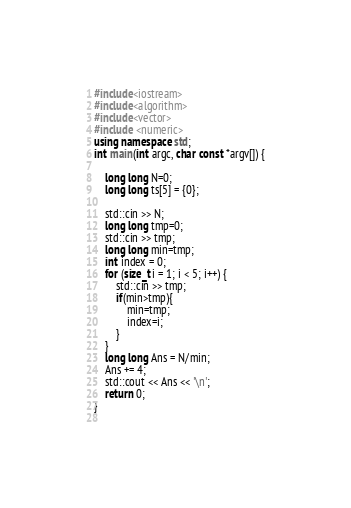Convert code to text. <code><loc_0><loc_0><loc_500><loc_500><_C++_>#include<iostream>
#include<algorithm>
#include<vector>
#include <numeric>
using namespace std;
int main(int argc, char const *argv[]) {

    long long N=0;
    long long ts[5] = {0};

    std::cin >> N;
    long long tmp=0;
    std::cin >> tmp;
    long long min=tmp;
    int index = 0;
    for (size_t i = 1; i < 5; i++) {
        std::cin >> tmp;
        if(min>tmp){
            min=tmp;
            index=i;
        }
    }
    long long Ans = N/min;
    Ans += 4;
    std::cout << Ans << '\n';
    return 0;
}
 
</code> 